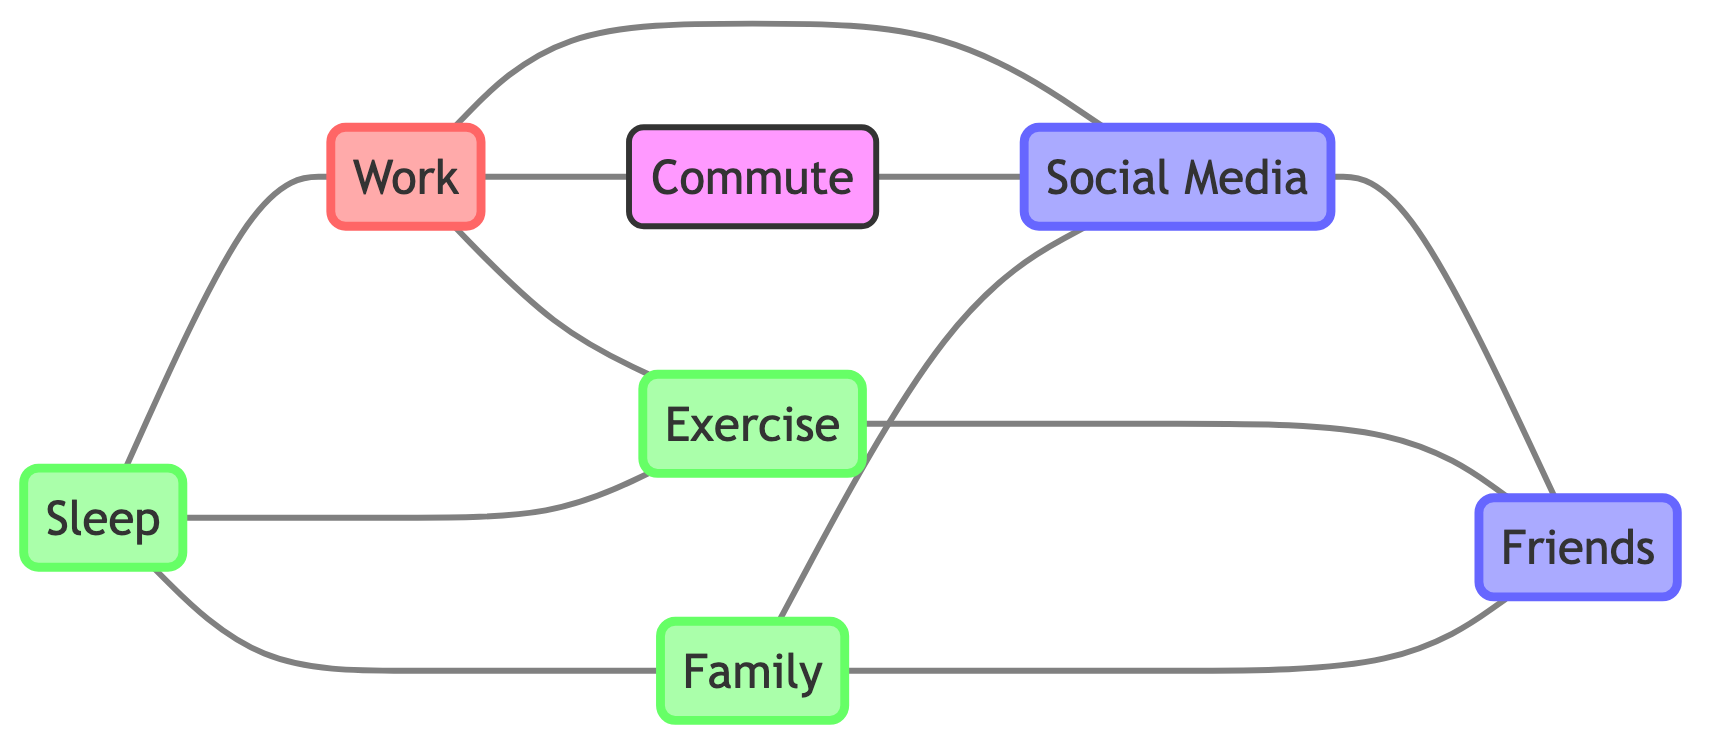What's the total number of nodes in the diagram? The diagram includes the elements: Work, Commute, Social Media, Exercise, Friends, Family, and Sleep. Counting these elements, we find a total of 7 nodes.
Answer: 7 How many connections does the element 'Social Media' have? The element 'Social Media' is connected to Work, Commute, Friends, and Family, totaling 4 connections.
Answer: 4 What is the relationship between 'Work' and 'Exercise'? 'Work' has a direct connection to 'Exercise', indicating that they are related in the context of the diagram.
Answer: Direct connection Which two elements are connected to both 'Commute' and 'Social Media'? The elements that connect both 'Commute' and 'Social Media' are Work and Friends.
Answer: Work and Friends Which activity requires Sleep as a component? The diagram shows that Sleep is connected to Work, Exercise, and Family. Thus, all these activities require Sleep in their daily schedule.
Answer: Work, Exercise, and Family How many elements are connected to 'Friends'? The element 'Friends' connects to Social Media and Exercise. Therefore, it has 2 connections.
Answer: 2 What is the significance of 'Family' in relation to 'Friends'? 'Family' is directly connected to 'Friends', indicating a relationship that suggests social interactions or support within the context of the diagram.
Answer: Direct connection Which elements are interconnected through 'Work'? The elements connected via 'Work' are Commute, Social Media, and Exercise.
Answer: Commute, Social Media, and Exercise How many edges are in the diagram? To find the total edges, we can count the lines connecting the nodes: there are 9 distinct connections listed.
Answer: 9 